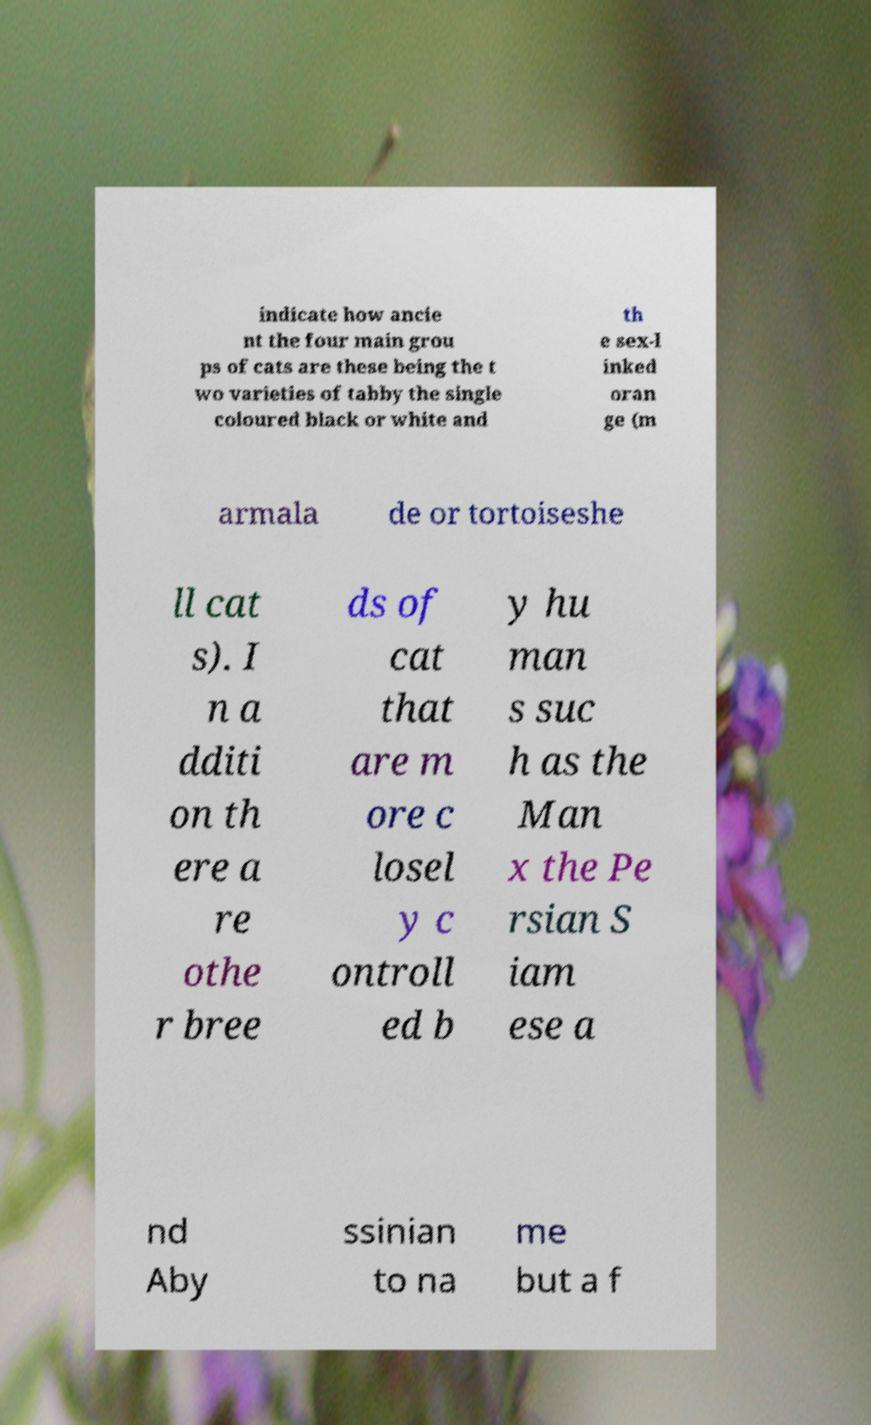Can you accurately transcribe the text from the provided image for me? indicate how ancie nt the four main grou ps of cats are these being the t wo varieties of tabby the single coloured black or white and th e sex-l inked oran ge (m armala de or tortoiseshe ll cat s). I n a dditi on th ere a re othe r bree ds of cat that are m ore c losel y c ontroll ed b y hu man s suc h as the Man x the Pe rsian S iam ese a nd Aby ssinian to na me but a f 